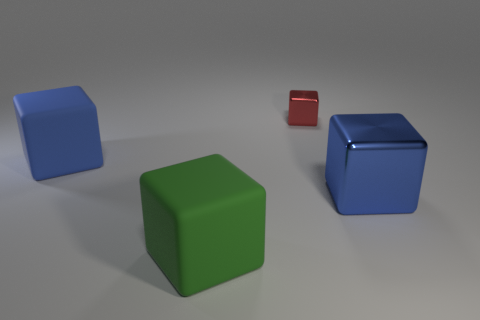Is there anything else that has the same size as the red thing?
Your answer should be very brief. No. What number of other objects are the same material as the small object?
Your answer should be very brief. 1. What is the tiny thing made of?
Offer a very short reply. Metal. How many green rubber objects are the same shape as the tiny red metal thing?
Your answer should be very brief. 1. There is another block that is the same color as the big metallic block; what material is it?
Keep it short and to the point. Rubber. Is there any other thing that is the same shape as the tiny thing?
Offer a very short reply. Yes. There is a metal thing on the right side of the small cube behind the metal cube right of the red shiny thing; what is its color?
Your answer should be very brief. Blue. How many big objects are either blue matte things or rubber cylinders?
Your response must be concise. 1. Are there the same number of big blue shiny cubes on the left side of the red thing and blue rubber blocks?
Keep it short and to the point. No. Are there any green rubber things to the left of the green rubber block?
Offer a terse response. No. 